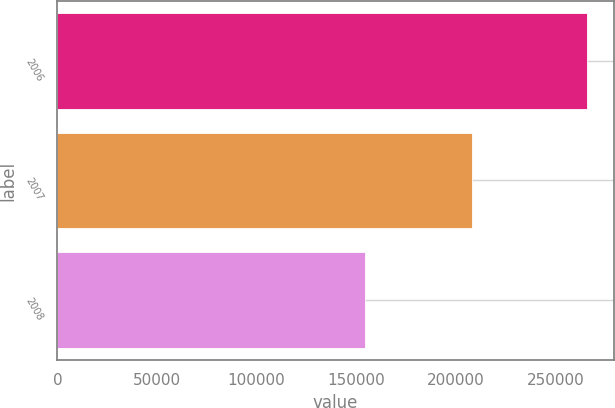<chart> <loc_0><loc_0><loc_500><loc_500><bar_chart><fcel>2006<fcel>2007<fcel>2008<nl><fcel>266044<fcel>208131<fcel>154647<nl></chart> 